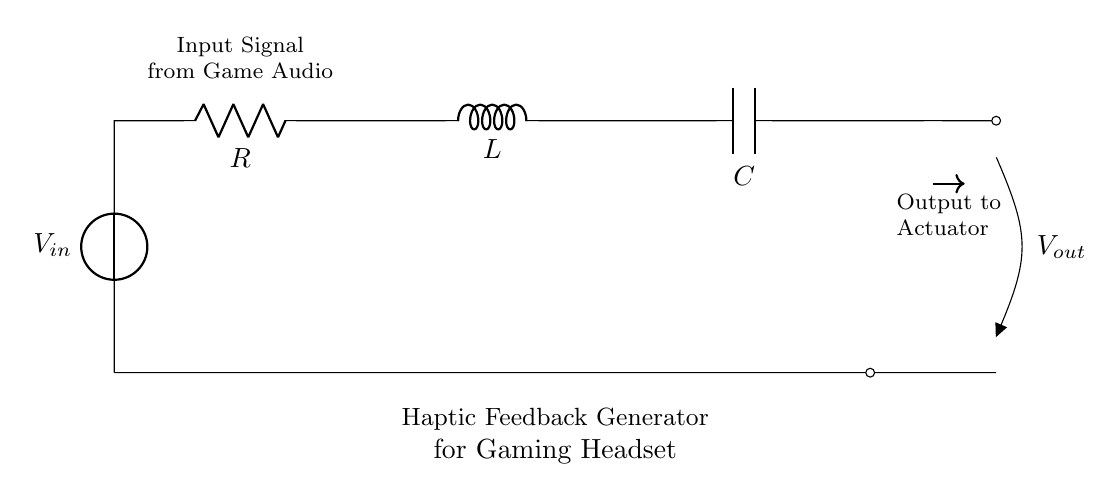What is the input component in this circuit? The input component is identified as the voltage source marked V_in, which supplies the necessary electrical energy for the circuit to function.
Answer: voltage source What does the capacitor represent in this circuit? The capacitor, labeled C, represents a component that stores electrical energy temporarily and affects the timing characteristics of the circuit, particularly in an RLC configuration.
Answer: energy storage How many components are in this circuit? There are four components in the circuit: a voltage source, a resistor, an inductor, and a capacitor. Each serves its specific role within the RLC configuration.
Answer: four What type of circuit is represented here? The circuit depicted is a series RLC circuit since the resistor, inductor, and capacitor are connected in series, sharing the same current path throughout.
Answer: series RLC What is the purpose of this circuit? The purpose of this circuit is to generate haptic feedback for gaming headsets by converting electrical signals into mechanical vibrations that enhance the gaming experience.
Answer: haptic feedback generation What is the output of this circuit? The output is indicated as V_out, which is the voltage across the actuator that translates the electrical signals into physical motion, providing the haptic feedback.
Answer: voltage to actuator What is affected by the values of R, L, and C in this circuit? The values of R, L, and C affect the resonant frequency of the circuit, which determines how it responds to different input signals, thus impacting performance in generating feedback.
Answer: resonant frequency 